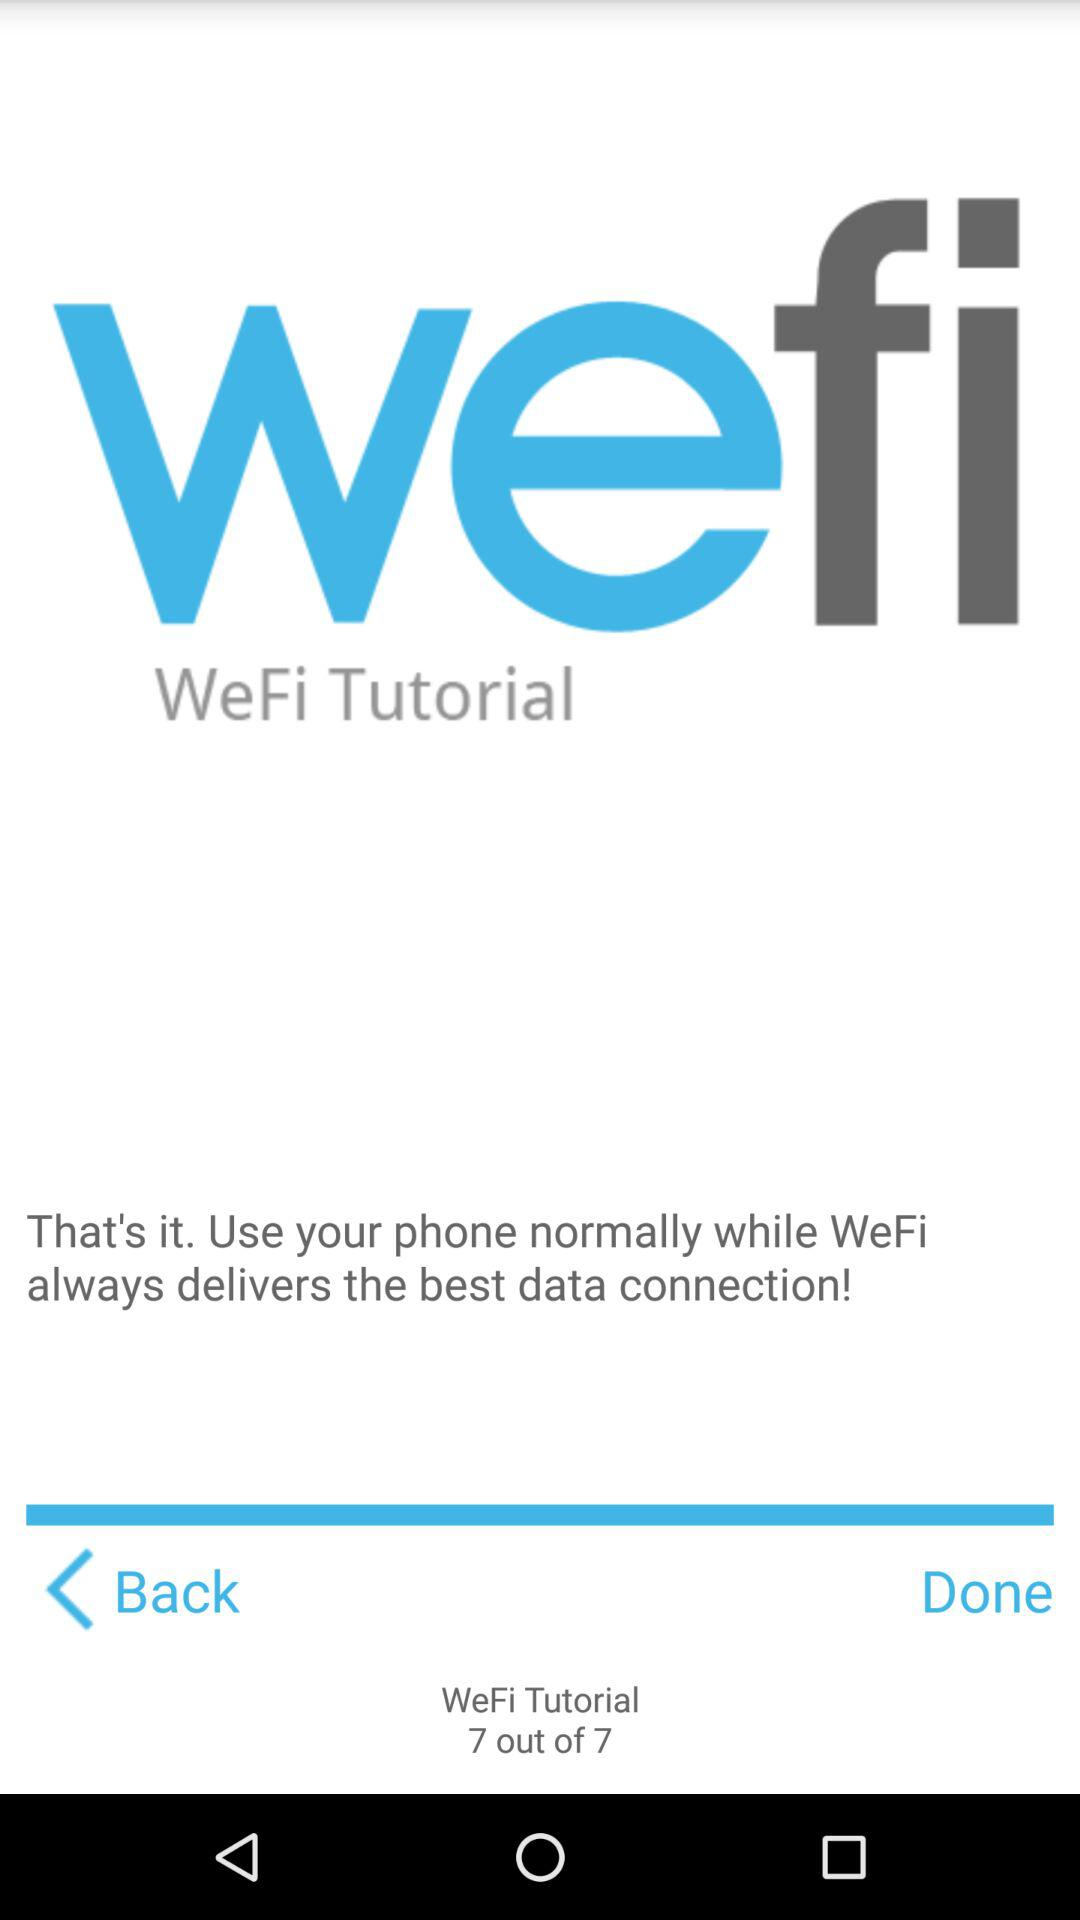How many tutorials in total are there? There are 7 tutorials in total. 